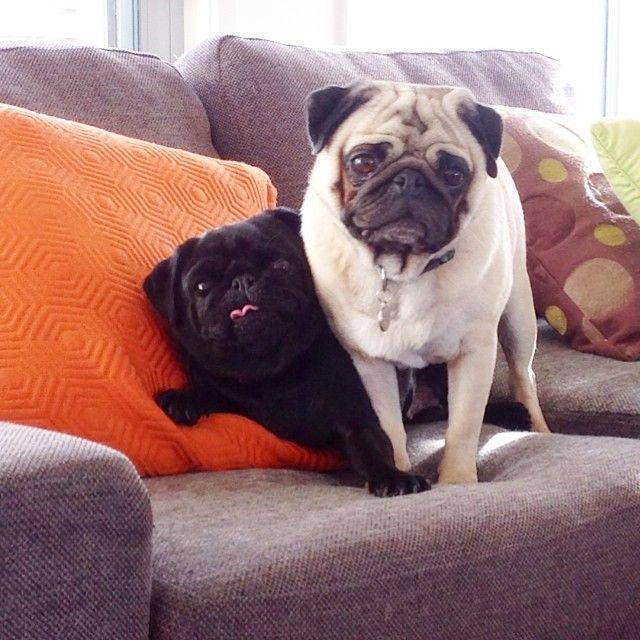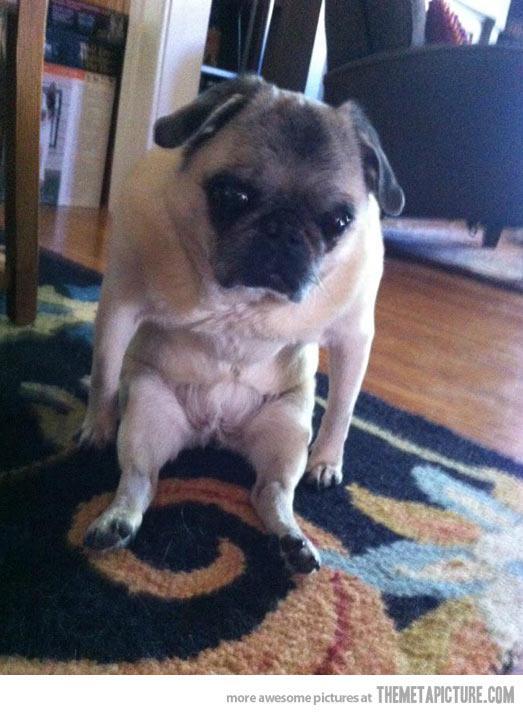The first image is the image on the left, the second image is the image on the right. For the images shown, is this caption "There is a pug lying on its back in the left image." true? Answer yes or no. No. 